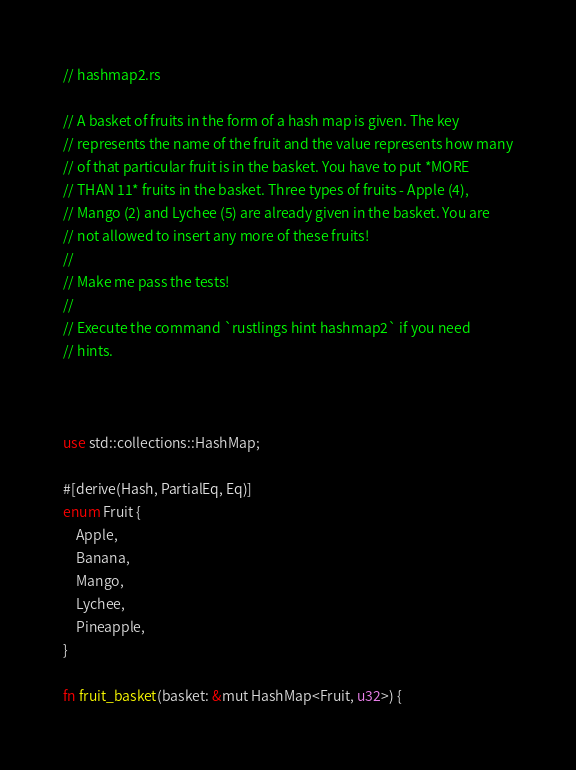<code> <loc_0><loc_0><loc_500><loc_500><_Rust_>// hashmap2.rs

// A basket of fruits in the form of a hash map is given. The key
// represents the name of the fruit and the value represents how many
// of that particular fruit is in the basket. You have to put *MORE
// THAN 11* fruits in the basket. Three types of fruits - Apple (4),
// Mango (2) and Lychee (5) are already given in the basket. You are
// not allowed to insert any more of these fruits!
//
// Make me pass the tests!
//
// Execute the command `rustlings hint hashmap2` if you need
// hints.



use std::collections::HashMap;

#[derive(Hash, PartialEq, Eq)]
enum Fruit {
    Apple,
    Banana,
    Mango,
    Lychee,
    Pineapple,
}

fn fruit_basket(basket: &mut HashMap<Fruit, u32>) {</code> 